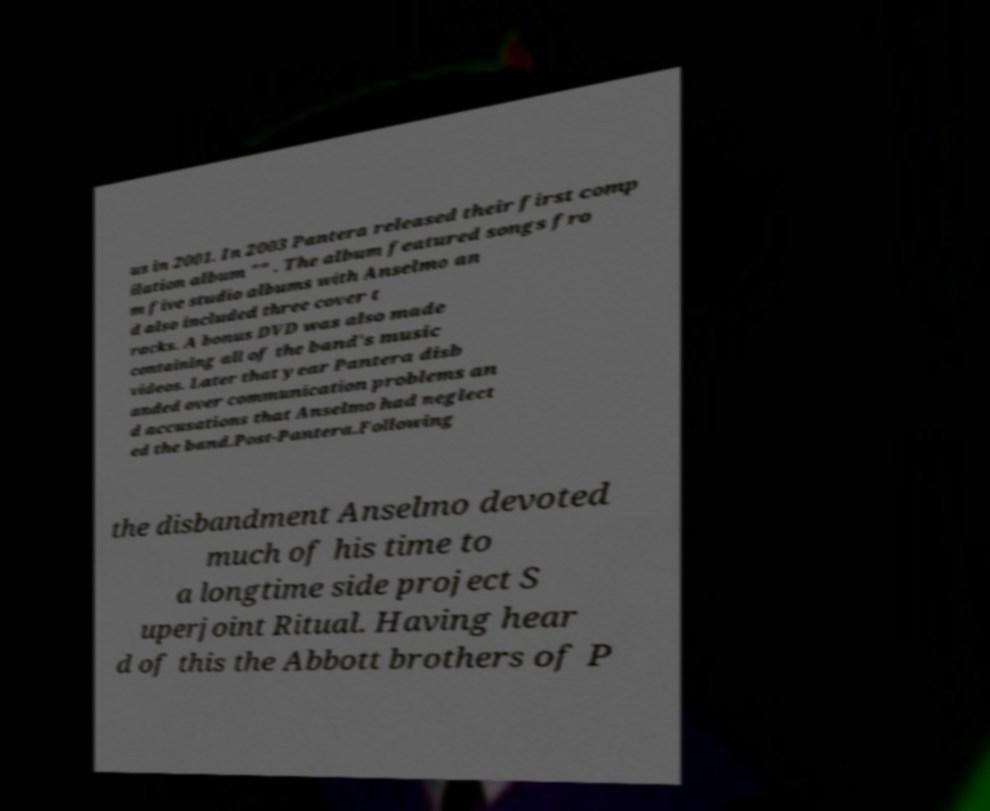Please read and relay the text visible in this image. What does it say? us in 2001. In 2003 Pantera released their first comp ilation album "" . The album featured songs fro m five studio albums with Anselmo an d also included three cover t racks. A bonus DVD was also made containing all of the band's music videos. Later that year Pantera disb anded over communication problems an d accusations that Anselmo had neglect ed the band.Post-Pantera.Following the disbandment Anselmo devoted much of his time to a longtime side project S uperjoint Ritual. Having hear d of this the Abbott brothers of P 